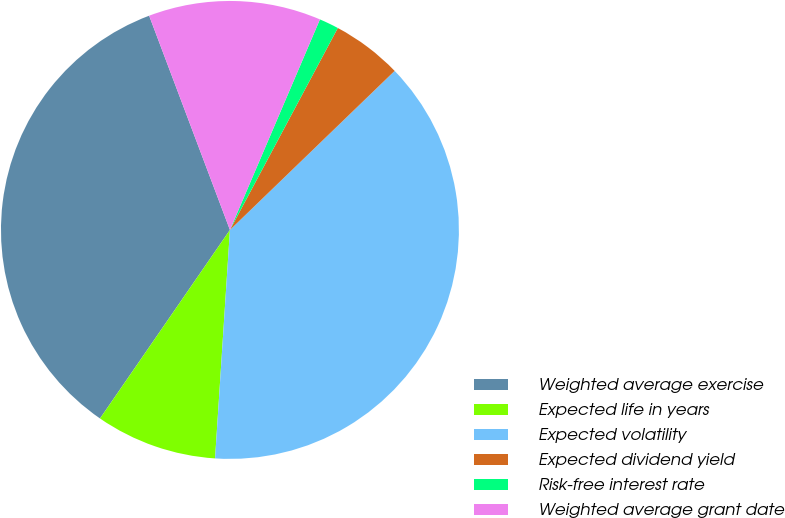Convert chart to OTSL. <chart><loc_0><loc_0><loc_500><loc_500><pie_chart><fcel>Weighted average exercise<fcel>Expected life in years<fcel>Expected volatility<fcel>Expected dividend yield<fcel>Risk-free interest rate<fcel>Weighted average grant date<nl><fcel>34.66%<fcel>8.57%<fcel>38.26%<fcel>4.97%<fcel>1.38%<fcel>12.17%<nl></chart> 